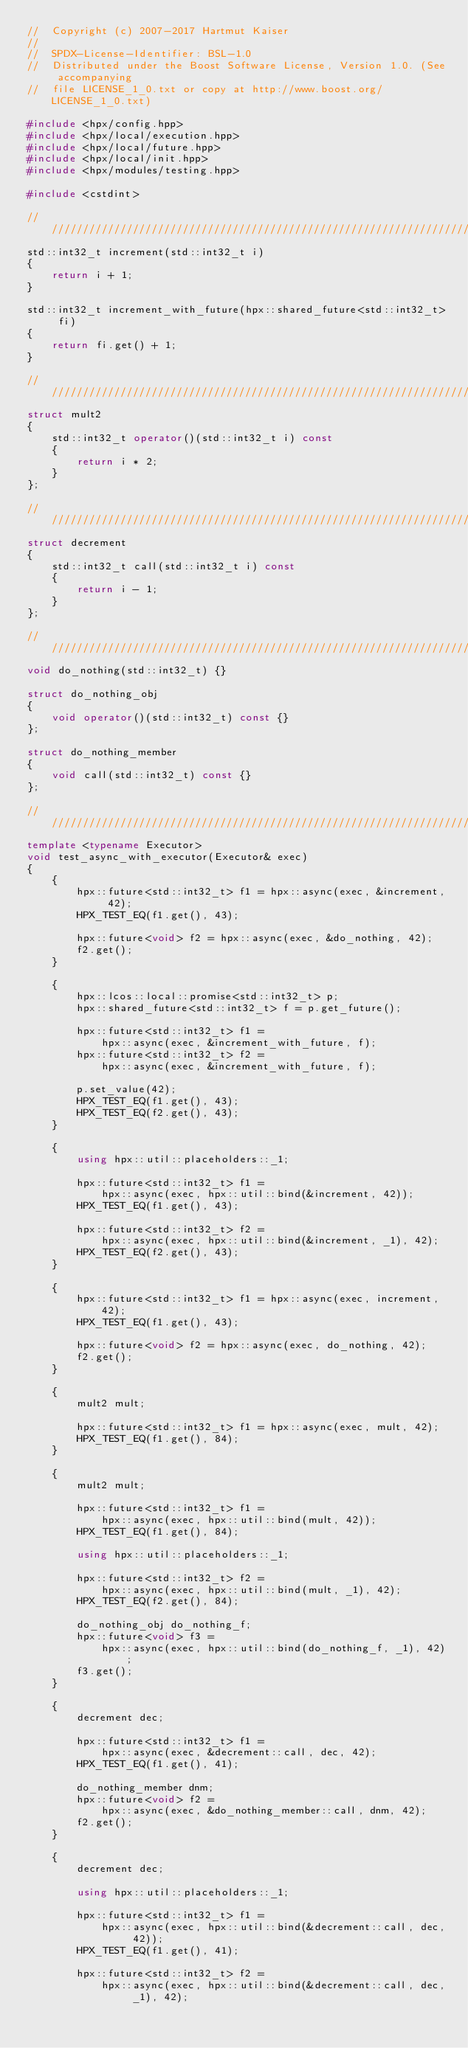<code> <loc_0><loc_0><loc_500><loc_500><_C++_>//  Copyright (c) 2007-2017 Hartmut Kaiser
//
//  SPDX-License-Identifier: BSL-1.0
//  Distributed under the Boost Software License, Version 1.0. (See accompanying
//  file LICENSE_1_0.txt or copy at http://www.boost.org/LICENSE_1_0.txt)

#include <hpx/config.hpp>
#include <hpx/local/execution.hpp>
#include <hpx/local/future.hpp>
#include <hpx/local/init.hpp>
#include <hpx/modules/testing.hpp>

#include <cstdint>

///////////////////////////////////////////////////////////////////////////////
std::int32_t increment(std::int32_t i)
{
    return i + 1;
}

std::int32_t increment_with_future(hpx::shared_future<std::int32_t> fi)
{
    return fi.get() + 1;
}

///////////////////////////////////////////////////////////////////////////////
struct mult2
{
    std::int32_t operator()(std::int32_t i) const
    {
        return i * 2;
    }
};

///////////////////////////////////////////////////////////////////////////////
struct decrement
{
    std::int32_t call(std::int32_t i) const
    {
        return i - 1;
    }
};

///////////////////////////////////////////////////////////////////////////////
void do_nothing(std::int32_t) {}

struct do_nothing_obj
{
    void operator()(std::int32_t) const {}
};

struct do_nothing_member
{
    void call(std::int32_t) const {}
};

///////////////////////////////////////////////////////////////////////////////
template <typename Executor>
void test_async_with_executor(Executor& exec)
{
    {
        hpx::future<std::int32_t> f1 = hpx::async(exec, &increment, 42);
        HPX_TEST_EQ(f1.get(), 43);

        hpx::future<void> f2 = hpx::async(exec, &do_nothing, 42);
        f2.get();
    }

    {
        hpx::lcos::local::promise<std::int32_t> p;
        hpx::shared_future<std::int32_t> f = p.get_future();

        hpx::future<std::int32_t> f1 =
            hpx::async(exec, &increment_with_future, f);
        hpx::future<std::int32_t> f2 =
            hpx::async(exec, &increment_with_future, f);

        p.set_value(42);
        HPX_TEST_EQ(f1.get(), 43);
        HPX_TEST_EQ(f2.get(), 43);
    }

    {
        using hpx::util::placeholders::_1;

        hpx::future<std::int32_t> f1 =
            hpx::async(exec, hpx::util::bind(&increment, 42));
        HPX_TEST_EQ(f1.get(), 43);

        hpx::future<std::int32_t> f2 =
            hpx::async(exec, hpx::util::bind(&increment, _1), 42);
        HPX_TEST_EQ(f2.get(), 43);
    }

    {
        hpx::future<std::int32_t> f1 = hpx::async(exec, increment, 42);
        HPX_TEST_EQ(f1.get(), 43);

        hpx::future<void> f2 = hpx::async(exec, do_nothing, 42);
        f2.get();
    }

    {
        mult2 mult;

        hpx::future<std::int32_t> f1 = hpx::async(exec, mult, 42);
        HPX_TEST_EQ(f1.get(), 84);
    }

    {
        mult2 mult;

        hpx::future<std::int32_t> f1 =
            hpx::async(exec, hpx::util::bind(mult, 42));
        HPX_TEST_EQ(f1.get(), 84);

        using hpx::util::placeholders::_1;

        hpx::future<std::int32_t> f2 =
            hpx::async(exec, hpx::util::bind(mult, _1), 42);
        HPX_TEST_EQ(f2.get(), 84);

        do_nothing_obj do_nothing_f;
        hpx::future<void> f3 =
            hpx::async(exec, hpx::util::bind(do_nothing_f, _1), 42);
        f3.get();
    }

    {
        decrement dec;

        hpx::future<std::int32_t> f1 =
            hpx::async(exec, &decrement::call, dec, 42);
        HPX_TEST_EQ(f1.get(), 41);

        do_nothing_member dnm;
        hpx::future<void> f2 =
            hpx::async(exec, &do_nothing_member::call, dnm, 42);
        f2.get();
    }

    {
        decrement dec;

        using hpx::util::placeholders::_1;

        hpx::future<std::int32_t> f1 =
            hpx::async(exec, hpx::util::bind(&decrement::call, dec, 42));
        HPX_TEST_EQ(f1.get(), 41);

        hpx::future<std::int32_t> f2 =
            hpx::async(exec, hpx::util::bind(&decrement::call, dec, _1), 42);</code> 